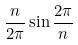<formula> <loc_0><loc_0><loc_500><loc_500>\frac { n } { 2 \pi } \sin \frac { 2 \pi } { n }</formula> 